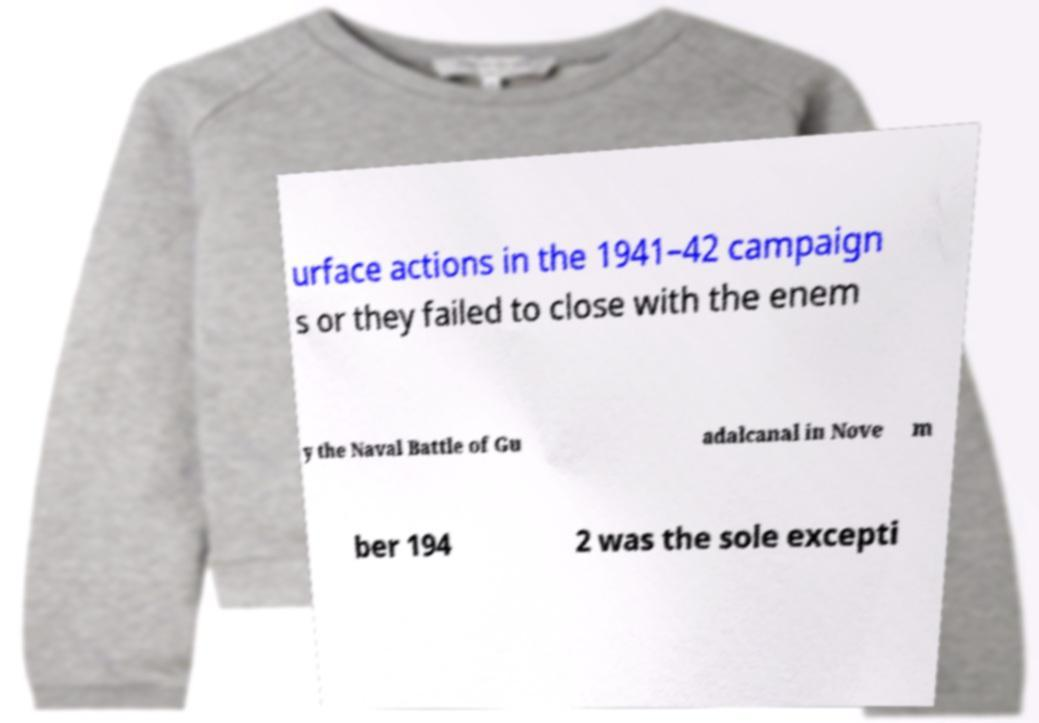Can you read and provide the text displayed in the image?This photo seems to have some interesting text. Can you extract and type it out for me? urface actions in the 1941–42 campaign s or they failed to close with the enem y the Naval Battle of Gu adalcanal in Nove m ber 194 2 was the sole excepti 